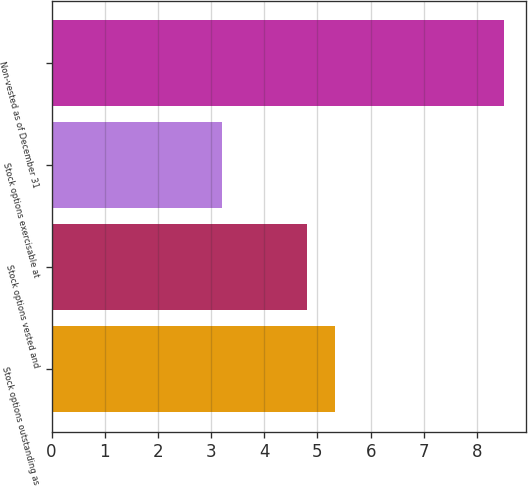Convert chart to OTSL. <chart><loc_0><loc_0><loc_500><loc_500><bar_chart><fcel>Stock options outstanding as<fcel>Stock options vested and<fcel>Stock options exercisable at<fcel>Non-vested as of December 31<nl><fcel>5.33<fcel>4.8<fcel>3.2<fcel>8.5<nl></chart> 